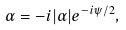<formula> <loc_0><loc_0><loc_500><loc_500>\alpha = - i | \alpha | e ^ { - i \psi / 2 } ,</formula> 